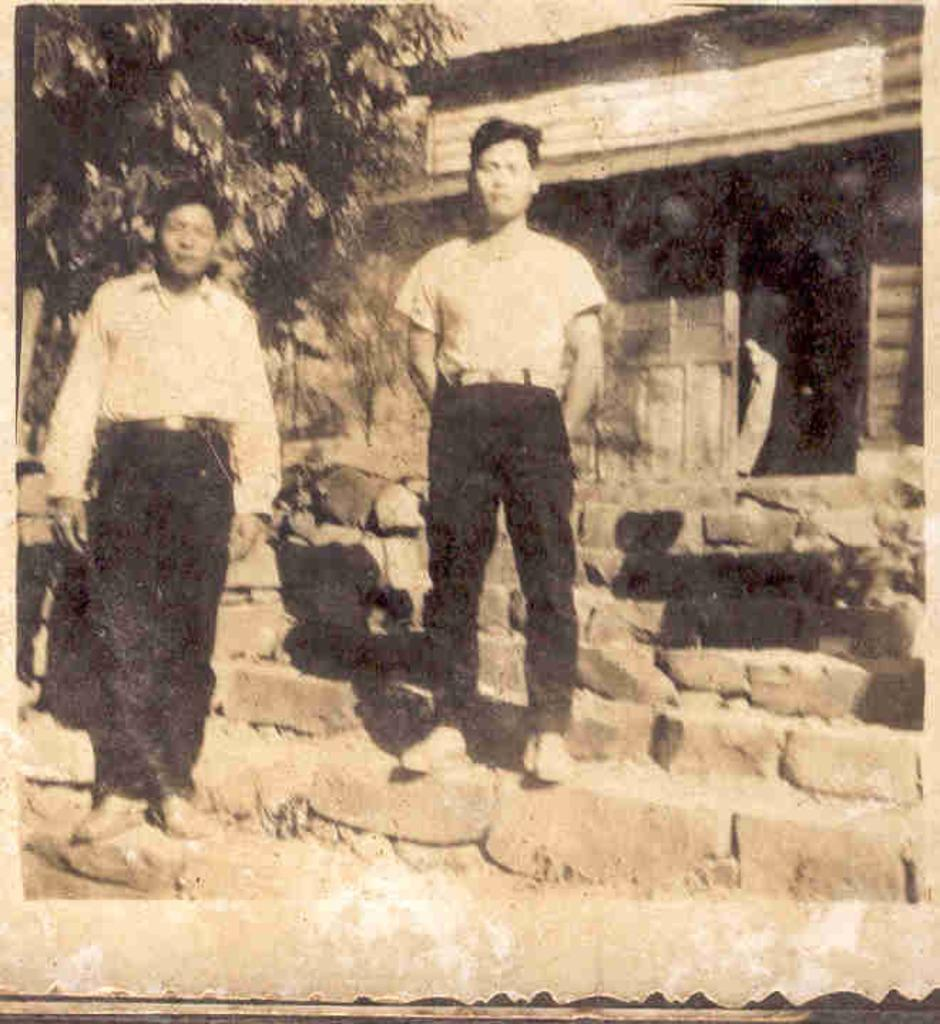How many people are in the image? There are two persons in the image. What are the two persons doing in the image? The two persons are standing on the steps. What type of vegetation can be seen in the image? There is a tree in the image. What type of structure is visible in the image? There is a house in the image. What type of sack can be seen being carried by the persons in the image? There is no sack visible in the image; the two persons are standing on the steps. What type of motion can be seen in the image? There is no motion visible in the image; the two persons are standing still on the steps. 